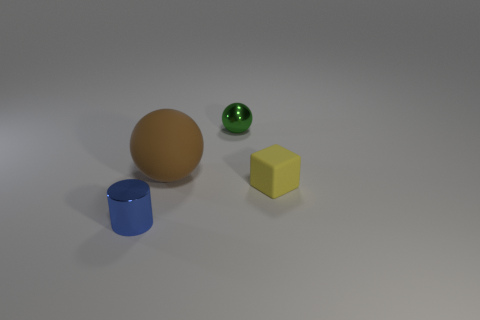What number of blue things have the same size as the green thing?
Your response must be concise. 1. Do the tiny block and the tiny sphere have the same color?
Make the answer very short. No. Is the object in front of the small rubber block made of the same material as the small thing behind the small yellow object?
Keep it short and to the point. Yes. Is the number of purple metallic cubes greater than the number of big matte spheres?
Give a very brief answer. No. Is there any other thing that is the same color as the small block?
Provide a short and direct response. No. Is the material of the small yellow cube the same as the brown ball?
Make the answer very short. Yes. Are there fewer gray rubber spheres than tiny rubber blocks?
Offer a very short reply. Yes. Does the small matte thing have the same shape as the tiny blue object?
Offer a very short reply. No. What color is the tiny ball?
Provide a succinct answer. Green. How many brown objects are large rubber cylinders or large balls?
Provide a short and direct response. 1. 